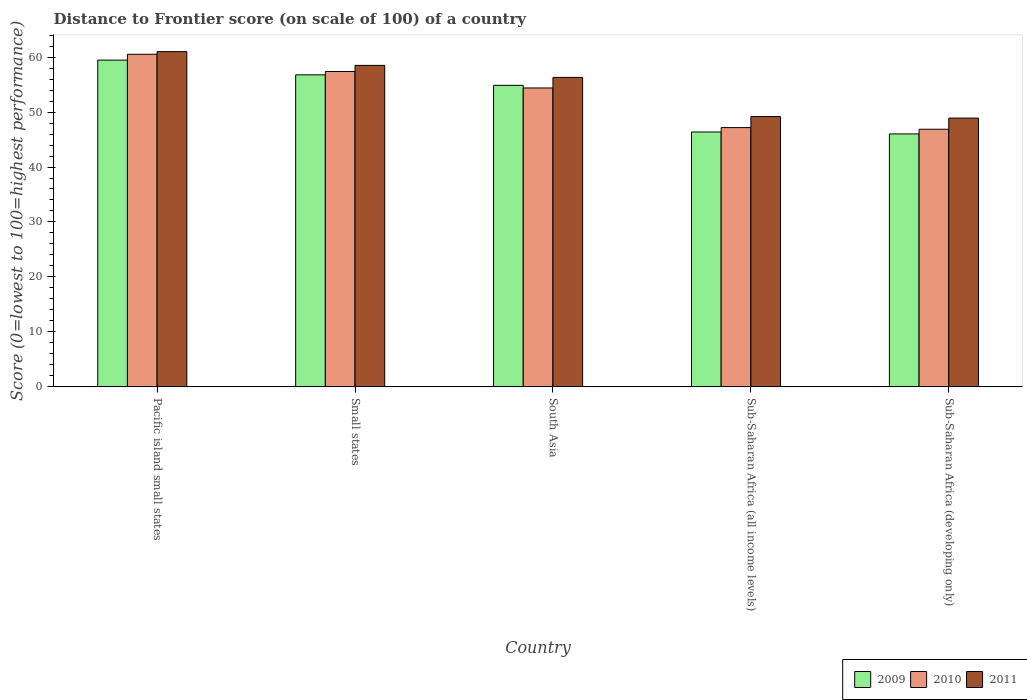How many different coloured bars are there?
Your answer should be compact. 3. How many groups of bars are there?
Give a very brief answer. 5. How many bars are there on the 4th tick from the left?
Your answer should be compact. 3. How many bars are there on the 1st tick from the right?
Provide a succinct answer. 3. What is the label of the 5th group of bars from the left?
Your response must be concise. Sub-Saharan Africa (developing only). What is the distance to frontier score of in 2010 in South Asia?
Keep it short and to the point. 54.38. Across all countries, what is the maximum distance to frontier score of in 2010?
Your answer should be very brief. 60.51. Across all countries, what is the minimum distance to frontier score of in 2010?
Keep it short and to the point. 46.87. In which country was the distance to frontier score of in 2011 maximum?
Provide a succinct answer. Pacific island small states. In which country was the distance to frontier score of in 2011 minimum?
Offer a very short reply. Sub-Saharan Africa (developing only). What is the total distance to frontier score of in 2011 in the graph?
Provide a short and direct response. 273.86. What is the difference between the distance to frontier score of in 2011 in South Asia and that in Sub-Saharan Africa (all income levels)?
Make the answer very short. 7.13. What is the difference between the distance to frontier score of in 2010 in Sub-Saharan Africa (all income levels) and the distance to frontier score of in 2011 in Sub-Saharan Africa (developing only)?
Ensure brevity in your answer.  -1.73. What is the average distance to frontier score of in 2011 per country?
Your answer should be very brief. 54.77. What is the difference between the distance to frontier score of of/in 2011 and distance to frontier score of of/in 2010 in Small states?
Offer a terse response. 1.11. In how many countries, is the distance to frontier score of in 2011 greater than 54?
Your answer should be very brief. 3. What is the ratio of the distance to frontier score of in 2010 in Small states to that in Sub-Saharan Africa (all income levels)?
Provide a short and direct response. 1.22. Is the distance to frontier score of in 2010 in Pacific island small states less than that in Small states?
Make the answer very short. No. What is the difference between the highest and the second highest distance to frontier score of in 2010?
Offer a very short reply. -3.13. What is the difference between the highest and the lowest distance to frontier score of in 2011?
Your answer should be compact. 12.09. Is the sum of the distance to frontier score of in 2010 in Pacific island small states and Sub-Saharan Africa (developing only) greater than the maximum distance to frontier score of in 2011 across all countries?
Provide a short and direct response. Yes. What does the 2nd bar from the left in Sub-Saharan Africa (all income levels) represents?
Make the answer very short. 2010. What does the 3rd bar from the right in Sub-Saharan Africa (all income levels) represents?
Provide a short and direct response. 2009. Is it the case that in every country, the sum of the distance to frontier score of in 2010 and distance to frontier score of in 2009 is greater than the distance to frontier score of in 2011?
Keep it short and to the point. Yes. How many bars are there?
Your answer should be compact. 15. Are all the bars in the graph horizontal?
Provide a short and direct response. No. Are the values on the major ticks of Y-axis written in scientific E-notation?
Offer a very short reply. No. Where does the legend appear in the graph?
Your answer should be compact. Bottom right. What is the title of the graph?
Offer a very short reply. Distance to Frontier score (on scale of 100) of a country. Does "1981" appear as one of the legend labels in the graph?
Give a very brief answer. No. What is the label or title of the X-axis?
Keep it short and to the point. Country. What is the label or title of the Y-axis?
Offer a very short reply. Score (0=lowest to 100=highest performance). What is the Score (0=lowest to 100=highest performance) of 2009 in Pacific island small states?
Your answer should be very brief. 59.45. What is the Score (0=lowest to 100=highest performance) of 2010 in Pacific island small states?
Your answer should be very brief. 60.51. What is the Score (0=lowest to 100=highest performance) in 2011 in Pacific island small states?
Provide a short and direct response. 60.99. What is the Score (0=lowest to 100=highest performance) of 2009 in Small states?
Your response must be concise. 56.77. What is the Score (0=lowest to 100=highest performance) of 2010 in Small states?
Provide a short and direct response. 57.38. What is the Score (0=lowest to 100=highest performance) of 2011 in Small states?
Your answer should be very brief. 58.49. What is the Score (0=lowest to 100=highest performance) in 2009 in South Asia?
Keep it short and to the point. 54.86. What is the Score (0=lowest to 100=highest performance) of 2010 in South Asia?
Offer a very short reply. 54.38. What is the Score (0=lowest to 100=highest performance) of 2011 in South Asia?
Offer a terse response. 56.3. What is the Score (0=lowest to 100=highest performance) of 2009 in Sub-Saharan Africa (all income levels)?
Make the answer very short. 46.37. What is the Score (0=lowest to 100=highest performance) of 2010 in Sub-Saharan Africa (all income levels)?
Give a very brief answer. 47.17. What is the Score (0=lowest to 100=highest performance) in 2011 in Sub-Saharan Africa (all income levels)?
Your response must be concise. 49.18. What is the Score (0=lowest to 100=highest performance) in 2009 in Sub-Saharan Africa (developing only)?
Your response must be concise. 46.02. What is the Score (0=lowest to 100=highest performance) in 2010 in Sub-Saharan Africa (developing only)?
Offer a very short reply. 46.87. What is the Score (0=lowest to 100=highest performance) in 2011 in Sub-Saharan Africa (developing only)?
Offer a very short reply. 48.9. Across all countries, what is the maximum Score (0=lowest to 100=highest performance) in 2009?
Your response must be concise. 59.45. Across all countries, what is the maximum Score (0=lowest to 100=highest performance) in 2010?
Ensure brevity in your answer.  60.51. Across all countries, what is the maximum Score (0=lowest to 100=highest performance) in 2011?
Offer a very short reply. 60.99. Across all countries, what is the minimum Score (0=lowest to 100=highest performance) of 2009?
Provide a succinct answer. 46.02. Across all countries, what is the minimum Score (0=lowest to 100=highest performance) of 2010?
Give a very brief answer. 46.87. Across all countries, what is the minimum Score (0=lowest to 100=highest performance) of 2011?
Offer a terse response. 48.9. What is the total Score (0=lowest to 100=highest performance) of 2009 in the graph?
Make the answer very short. 263.47. What is the total Score (0=lowest to 100=highest performance) of 2010 in the graph?
Provide a succinct answer. 266.31. What is the total Score (0=lowest to 100=highest performance) of 2011 in the graph?
Your answer should be very brief. 273.86. What is the difference between the Score (0=lowest to 100=highest performance) in 2009 in Pacific island small states and that in Small states?
Give a very brief answer. 2.68. What is the difference between the Score (0=lowest to 100=highest performance) in 2010 in Pacific island small states and that in Small states?
Your answer should be compact. 3.13. What is the difference between the Score (0=lowest to 100=highest performance) in 2011 in Pacific island small states and that in Small states?
Offer a terse response. 2.5. What is the difference between the Score (0=lowest to 100=highest performance) of 2009 in Pacific island small states and that in South Asia?
Keep it short and to the point. 4.59. What is the difference between the Score (0=lowest to 100=highest performance) of 2010 in Pacific island small states and that in South Asia?
Offer a terse response. 6.13. What is the difference between the Score (0=lowest to 100=highest performance) in 2011 in Pacific island small states and that in South Asia?
Your response must be concise. 4.69. What is the difference between the Score (0=lowest to 100=highest performance) in 2009 in Pacific island small states and that in Sub-Saharan Africa (all income levels)?
Give a very brief answer. 13.08. What is the difference between the Score (0=lowest to 100=highest performance) of 2010 in Pacific island small states and that in Sub-Saharan Africa (all income levels)?
Provide a succinct answer. 13.34. What is the difference between the Score (0=lowest to 100=highest performance) in 2011 in Pacific island small states and that in Sub-Saharan Africa (all income levels)?
Offer a terse response. 11.81. What is the difference between the Score (0=lowest to 100=highest performance) of 2009 in Pacific island small states and that in Sub-Saharan Africa (developing only)?
Provide a succinct answer. 13.43. What is the difference between the Score (0=lowest to 100=highest performance) in 2010 in Pacific island small states and that in Sub-Saharan Africa (developing only)?
Make the answer very short. 13.64. What is the difference between the Score (0=lowest to 100=highest performance) in 2011 in Pacific island small states and that in Sub-Saharan Africa (developing only)?
Ensure brevity in your answer.  12.09. What is the difference between the Score (0=lowest to 100=highest performance) in 2009 in Small states and that in South Asia?
Ensure brevity in your answer.  1.92. What is the difference between the Score (0=lowest to 100=highest performance) in 2010 in Small states and that in South Asia?
Your answer should be very brief. 3. What is the difference between the Score (0=lowest to 100=highest performance) of 2011 in Small states and that in South Asia?
Offer a very short reply. 2.19. What is the difference between the Score (0=lowest to 100=highest performance) of 2009 in Small states and that in Sub-Saharan Africa (all income levels)?
Ensure brevity in your answer.  10.4. What is the difference between the Score (0=lowest to 100=highest performance) in 2010 in Small states and that in Sub-Saharan Africa (all income levels)?
Make the answer very short. 10.21. What is the difference between the Score (0=lowest to 100=highest performance) of 2011 in Small states and that in Sub-Saharan Africa (all income levels)?
Your response must be concise. 9.31. What is the difference between the Score (0=lowest to 100=highest performance) of 2009 in Small states and that in Sub-Saharan Africa (developing only)?
Provide a short and direct response. 10.75. What is the difference between the Score (0=lowest to 100=highest performance) in 2010 in Small states and that in Sub-Saharan Africa (developing only)?
Offer a very short reply. 10.51. What is the difference between the Score (0=lowest to 100=highest performance) of 2011 in Small states and that in Sub-Saharan Africa (developing only)?
Your answer should be very brief. 9.59. What is the difference between the Score (0=lowest to 100=highest performance) in 2009 in South Asia and that in Sub-Saharan Africa (all income levels)?
Provide a short and direct response. 8.48. What is the difference between the Score (0=lowest to 100=highest performance) of 2010 in South Asia and that in Sub-Saharan Africa (all income levels)?
Provide a succinct answer. 7.21. What is the difference between the Score (0=lowest to 100=highest performance) of 2011 in South Asia and that in Sub-Saharan Africa (all income levels)?
Give a very brief answer. 7.13. What is the difference between the Score (0=lowest to 100=highest performance) of 2009 in South Asia and that in Sub-Saharan Africa (developing only)?
Keep it short and to the point. 8.84. What is the difference between the Score (0=lowest to 100=highest performance) in 2010 in South Asia and that in Sub-Saharan Africa (developing only)?
Keep it short and to the point. 7.51. What is the difference between the Score (0=lowest to 100=highest performance) of 2011 in South Asia and that in Sub-Saharan Africa (developing only)?
Keep it short and to the point. 7.4. What is the difference between the Score (0=lowest to 100=highest performance) of 2009 in Sub-Saharan Africa (all income levels) and that in Sub-Saharan Africa (developing only)?
Your response must be concise. 0.35. What is the difference between the Score (0=lowest to 100=highest performance) in 2010 in Sub-Saharan Africa (all income levels) and that in Sub-Saharan Africa (developing only)?
Offer a very short reply. 0.3. What is the difference between the Score (0=lowest to 100=highest performance) in 2011 in Sub-Saharan Africa (all income levels) and that in Sub-Saharan Africa (developing only)?
Keep it short and to the point. 0.28. What is the difference between the Score (0=lowest to 100=highest performance) of 2009 in Pacific island small states and the Score (0=lowest to 100=highest performance) of 2010 in Small states?
Your answer should be very brief. 2.07. What is the difference between the Score (0=lowest to 100=highest performance) of 2009 in Pacific island small states and the Score (0=lowest to 100=highest performance) of 2011 in Small states?
Your response must be concise. 0.96. What is the difference between the Score (0=lowest to 100=highest performance) of 2010 in Pacific island small states and the Score (0=lowest to 100=highest performance) of 2011 in Small states?
Offer a terse response. 2.02. What is the difference between the Score (0=lowest to 100=highest performance) of 2009 in Pacific island small states and the Score (0=lowest to 100=highest performance) of 2010 in South Asia?
Your answer should be very brief. 5.07. What is the difference between the Score (0=lowest to 100=highest performance) of 2009 in Pacific island small states and the Score (0=lowest to 100=highest performance) of 2011 in South Asia?
Ensure brevity in your answer.  3.14. What is the difference between the Score (0=lowest to 100=highest performance) in 2010 in Pacific island small states and the Score (0=lowest to 100=highest performance) in 2011 in South Asia?
Give a very brief answer. 4.21. What is the difference between the Score (0=lowest to 100=highest performance) of 2009 in Pacific island small states and the Score (0=lowest to 100=highest performance) of 2010 in Sub-Saharan Africa (all income levels)?
Offer a terse response. 12.28. What is the difference between the Score (0=lowest to 100=highest performance) in 2009 in Pacific island small states and the Score (0=lowest to 100=highest performance) in 2011 in Sub-Saharan Africa (all income levels)?
Your answer should be compact. 10.27. What is the difference between the Score (0=lowest to 100=highest performance) of 2010 in Pacific island small states and the Score (0=lowest to 100=highest performance) of 2011 in Sub-Saharan Africa (all income levels)?
Your answer should be very brief. 11.33. What is the difference between the Score (0=lowest to 100=highest performance) of 2009 in Pacific island small states and the Score (0=lowest to 100=highest performance) of 2010 in Sub-Saharan Africa (developing only)?
Your response must be concise. 12.58. What is the difference between the Score (0=lowest to 100=highest performance) of 2009 in Pacific island small states and the Score (0=lowest to 100=highest performance) of 2011 in Sub-Saharan Africa (developing only)?
Offer a very short reply. 10.55. What is the difference between the Score (0=lowest to 100=highest performance) in 2010 in Pacific island small states and the Score (0=lowest to 100=highest performance) in 2011 in Sub-Saharan Africa (developing only)?
Ensure brevity in your answer.  11.61. What is the difference between the Score (0=lowest to 100=highest performance) in 2009 in Small states and the Score (0=lowest to 100=highest performance) in 2010 in South Asia?
Your answer should be very brief. 2.39. What is the difference between the Score (0=lowest to 100=highest performance) of 2009 in Small states and the Score (0=lowest to 100=highest performance) of 2011 in South Asia?
Provide a succinct answer. 0.47. What is the difference between the Score (0=lowest to 100=highest performance) of 2010 in Small states and the Score (0=lowest to 100=highest performance) of 2011 in South Asia?
Your answer should be compact. 1.07. What is the difference between the Score (0=lowest to 100=highest performance) of 2009 in Small states and the Score (0=lowest to 100=highest performance) of 2010 in Sub-Saharan Africa (all income levels)?
Give a very brief answer. 9.6. What is the difference between the Score (0=lowest to 100=highest performance) of 2009 in Small states and the Score (0=lowest to 100=highest performance) of 2011 in Sub-Saharan Africa (all income levels)?
Offer a terse response. 7.6. What is the difference between the Score (0=lowest to 100=highest performance) in 2010 in Small states and the Score (0=lowest to 100=highest performance) in 2011 in Sub-Saharan Africa (all income levels)?
Offer a terse response. 8.2. What is the difference between the Score (0=lowest to 100=highest performance) in 2009 in Small states and the Score (0=lowest to 100=highest performance) in 2010 in Sub-Saharan Africa (developing only)?
Offer a very short reply. 9.9. What is the difference between the Score (0=lowest to 100=highest performance) of 2009 in Small states and the Score (0=lowest to 100=highest performance) of 2011 in Sub-Saharan Africa (developing only)?
Your response must be concise. 7.87. What is the difference between the Score (0=lowest to 100=highest performance) of 2010 in Small states and the Score (0=lowest to 100=highest performance) of 2011 in Sub-Saharan Africa (developing only)?
Ensure brevity in your answer.  8.48. What is the difference between the Score (0=lowest to 100=highest performance) of 2009 in South Asia and the Score (0=lowest to 100=highest performance) of 2010 in Sub-Saharan Africa (all income levels)?
Make the answer very short. 7.68. What is the difference between the Score (0=lowest to 100=highest performance) of 2009 in South Asia and the Score (0=lowest to 100=highest performance) of 2011 in Sub-Saharan Africa (all income levels)?
Offer a very short reply. 5.68. What is the difference between the Score (0=lowest to 100=highest performance) of 2010 in South Asia and the Score (0=lowest to 100=highest performance) of 2011 in Sub-Saharan Africa (all income levels)?
Offer a terse response. 5.21. What is the difference between the Score (0=lowest to 100=highest performance) in 2009 in South Asia and the Score (0=lowest to 100=highest performance) in 2010 in Sub-Saharan Africa (developing only)?
Give a very brief answer. 7.98. What is the difference between the Score (0=lowest to 100=highest performance) of 2009 in South Asia and the Score (0=lowest to 100=highest performance) of 2011 in Sub-Saharan Africa (developing only)?
Offer a terse response. 5.96. What is the difference between the Score (0=lowest to 100=highest performance) in 2010 in South Asia and the Score (0=lowest to 100=highest performance) in 2011 in Sub-Saharan Africa (developing only)?
Give a very brief answer. 5.48. What is the difference between the Score (0=lowest to 100=highest performance) of 2009 in Sub-Saharan Africa (all income levels) and the Score (0=lowest to 100=highest performance) of 2010 in Sub-Saharan Africa (developing only)?
Provide a short and direct response. -0.5. What is the difference between the Score (0=lowest to 100=highest performance) in 2009 in Sub-Saharan Africa (all income levels) and the Score (0=lowest to 100=highest performance) in 2011 in Sub-Saharan Africa (developing only)?
Ensure brevity in your answer.  -2.53. What is the difference between the Score (0=lowest to 100=highest performance) in 2010 in Sub-Saharan Africa (all income levels) and the Score (0=lowest to 100=highest performance) in 2011 in Sub-Saharan Africa (developing only)?
Your response must be concise. -1.73. What is the average Score (0=lowest to 100=highest performance) in 2009 per country?
Keep it short and to the point. 52.69. What is the average Score (0=lowest to 100=highest performance) of 2010 per country?
Offer a terse response. 53.26. What is the average Score (0=lowest to 100=highest performance) in 2011 per country?
Offer a terse response. 54.77. What is the difference between the Score (0=lowest to 100=highest performance) of 2009 and Score (0=lowest to 100=highest performance) of 2010 in Pacific island small states?
Your answer should be compact. -1.06. What is the difference between the Score (0=lowest to 100=highest performance) of 2009 and Score (0=lowest to 100=highest performance) of 2011 in Pacific island small states?
Provide a short and direct response. -1.54. What is the difference between the Score (0=lowest to 100=highest performance) in 2010 and Score (0=lowest to 100=highest performance) in 2011 in Pacific island small states?
Provide a succinct answer. -0.48. What is the difference between the Score (0=lowest to 100=highest performance) in 2009 and Score (0=lowest to 100=highest performance) in 2010 in Small states?
Keep it short and to the point. -0.61. What is the difference between the Score (0=lowest to 100=highest performance) in 2009 and Score (0=lowest to 100=highest performance) in 2011 in Small states?
Give a very brief answer. -1.72. What is the difference between the Score (0=lowest to 100=highest performance) in 2010 and Score (0=lowest to 100=highest performance) in 2011 in Small states?
Your answer should be very brief. -1.11. What is the difference between the Score (0=lowest to 100=highest performance) in 2009 and Score (0=lowest to 100=highest performance) in 2010 in South Asia?
Your response must be concise. 0.47. What is the difference between the Score (0=lowest to 100=highest performance) of 2009 and Score (0=lowest to 100=highest performance) of 2011 in South Asia?
Ensure brevity in your answer.  -1.45. What is the difference between the Score (0=lowest to 100=highest performance) of 2010 and Score (0=lowest to 100=highest performance) of 2011 in South Asia?
Keep it short and to the point. -1.92. What is the difference between the Score (0=lowest to 100=highest performance) of 2009 and Score (0=lowest to 100=highest performance) of 2010 in Sub-Saharan Africa (all income levels)?
Ensure brevity in your answer.  -0.8. What is the difference between the Score (0=lowest to 100=highest performance) in 2009 and Score (0=lowest to 100=highest performance) in 2011 in Sub-Saharan Africa (all income levels)?
Make the answer very short. -2.8. What is the difference between the Score (0=lowest to 100=highest performance) of 2010 and Score (0=lowest to 100=highest performance) of 2011 in Sub-Saharan Africa (all income levels)?
Your answer should be very brief. -2.01. What is the difference between the Score (0=lowest to 100=highest performance) of 2009 and Score (0=lowest to 100=highest performance) of 2010 in Sub-Saharan Africa (developing only)?
Your response must be concise. -0.85. What is the difference between the Score (0=lowest to 100=highest performance) in 2009 and Score (0=lowest to 100=highest performance) in 2011 in Sub-Saharan Africa (developing only)?
Provide a short and direct response. -2.88. What is the difference between the Score (0=lowest to 100=highest performance) of 2010 and Score (0=lowest to 100=highest performance) of 2011 in Sub-Saharan Africa (developing only)?
Provide a succinct answer. -2.03. What is the ratio of the Score (0=lowest to 100=highest performance) in 2009 in Pacific island small states to that in Small states?
Your response must be concise. 1.05. What is the ratio of the Score (0=lowest to 100=highest performance) of 2010 in Pacific island small states to that in Small states?
Offer a terse response. 1.05. What is the ratio of the Score (0=lowest to 100=highest performance) of 2011 in Pacific island small states to that in Small states?
Your answer should be very brief. 1.04. What is the ratio of the Score (0=lowest to 100=highest performance) in 2009 in Pacific island small states to that in South Asia?
Your response must be concise. 1.08. What is the ratio of the Score (0=lowest to 100=highest performance) in 2010 in Pacific island small states to that in South Asia?
Provide a short and direct response. 1.11. What is the ratio of the Score (0=lowest to 100=highest performance) in 2011 in Pacific island small states to that in South Asia?
Your answer should be very brief. 1.08. What is the ratio of the Score (0=lowest to 100=highest performance) in 2009 in Pacific island small states to that in Sub-Saharan Africa (all income levels)?
Give a very brief answer. 1.28. What is the ratio of the Score (0=lowest to 100=highest performance) of 2010 in Pacific island small states to that in Sub-Saharan Africa (all income levels)?
Make the answer very short. 1.28. What is the ratio of the Score (0=lowest to 100=highest performance) in 2011 in Pacific island small states to that in Sub-Saharan Africa (all income levels)?
Provide a succinct answer. 1.24. What is the ratio of the Score (0=lowest to 100=highest performance) in 2009 in Pacific island small states to that in Sub-Saharan Africa (developing only)?
Your answer should be compact. 1.29. What is the ratio of the Score (0=lowest to 100=highest performance) in 2010 in Pacific island small states to that in Sub-Saharan Africa (developing only)?
Your answer should be very brief. 1.29. What is the ratio of the Score (0=lowest to 100=highest performance) of 2011 in Pacific island small states to that in Sub-Saharan Africa (developing only)?
Give a very brief answer. 1.25. What is the ratio of the Score (0=lowest to 100=highest performance) of 2009 in Small states to that in South Asia?
Give a very brief answer. 1.03. What is the ratio of the Score (0=lowest to 100=highest performance) of 2010 in Small states to that in South Asia?
Offer a terse response. 1.06. What is the ratio of the Score (0=lowest to 100=highest performance) of 2011 in Small states to that in South Asia?
Provide a short and direct response. 1.04. What is the ratio of the Score (0=lowest to 100=highest performance) in 2009 in Small states to that in Sub-Saharan Africa (all income levels)?
Offer a terse response. 1.22. What is the ratio of the Score (0=lowest to 100=highest performance) in 2010 in Small states to that in Sub-Saharan Africa (all income levels)?
Your answer should be compact. 1.22. What is the ratio of the Score (0=lowest to 100=highest performance) in 2011 in Small states to that in Sub-Saharan Africa (all income levels)?
Your answer should be very brief. 1.19. What is the ratio of the Score (0=lowest to 100=highest performance) in 2009 in Small states to that in Sub-Saharan Africa (developing only)?
Offer a very short reply. 1.23. What is the ratio of the Score (0=lowest to 100=highest performance) in 2010 in Small states to that in Sub-Saharan Africa (developing only)?
Offer a terse response. 1.22. What is the ratio of the Score (0=lowest to 100=highest performance) of 2011 in Small states to that in Sub-Saharan Africa (developing only)?
Your response must be concise. 1.2. What is the ratio of the Score (0=lowest to 100=highest performance) of 2009 in South Asia to that in Sub-Saharan Africa (all income levels)?
Ensure brevity in your answer.  1.18. What is the ratio of the Score (0=lowest to 100=highest performance) of 2010 in South Asia to that in Sub-Saharan Africa (all income levels)?
Provide a succinct answer. 1.15. What is the ratio of the Score (0=lowest to 100=highest performance) of 2011 in South Asia to that in Sub-Saharan Africa (all income levels)?
Offer a very short reply. 1.14. What is the ratio of the Score (0=lowest to 100=highest performance) in 2009 in South Asia to that in Sub-Saharan Africa (developing only)?
Make the answer very short. 1.19. What is the ratio of the Score (0=lowest to 100=highest performance) in 2010 in South Asia to that in Sub-Saharan Africa (developing only)?
Provide a short and direct response. 1.16. What is the ratio of the Score (0=lowest to 100=highest performance) of 2011 in South Asia to that in Sub-Saharan Africa (developing only)?
Your answer should be compact. 1.15. What is the ratio of the Score (0=lowest to 100=highest performance) in 2009 in Sub-Saharan Africa (all income levels) to that in Sub-Saharan Africa (developing only)?
Your answer should be compact. 1.01. What is the ratio of the Score (0=lowest to 100=highest performance) of 2010 in Sub-Saharan Africa (all income levels) to that in Sub-Saharan Africa (developing only)?
Ensure brevity in your answer.  1.01. What is the difference between the highest and the second highest Score (0=lowest to 100=highest performance) of 2009?
Your answer should be very brief. 2.68. What is the difference between the highest and the second highest Score (0=lowest to 100=highest performance) in 2010?
Offer a very short reply. 3.13. What is the difference between the highest and the second highest Score (0=lowest to 100=highest performance) in 2011?
Offer a terse response. 2.5. What is the difference between the highest and the lowest Score (0=lowest to 100=highest performance) of 2009?
Make the answer very short. 13.43. What is the difference between the highest and the lowest Score (0=lowest to 100=highest performance) in 2010?
Offer a terse response. 13.64. What is the difference between the highest and the lowest Score (0=lowest to 100=highest performance) of 2011?
Offer a very short reply. 12.09. 